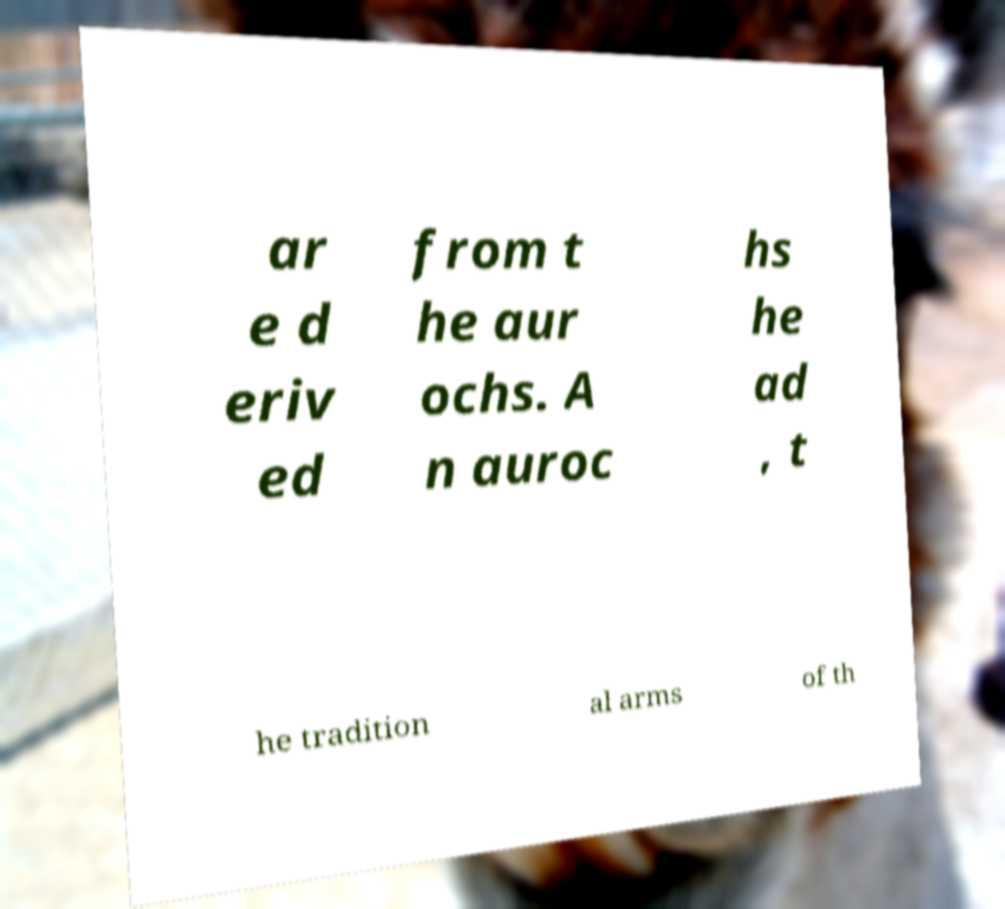What messages or text are displayed in this image? I need them in a readable, typed format. ar e d eriv ed from t he aur ochs. A n auroc hs he ad , t he tradition al arms of th 